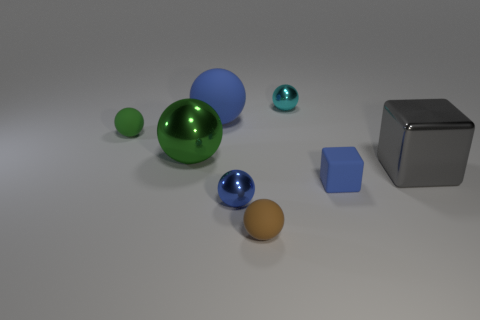Is there anything else that is the same size as the blue rubber block?
Provide a short and direct response. Yes. How many other things are the same color as the large rubber thing?
Provide a succinct answer. 2. Is the number of metallic objects that are on the right side of the tiny green matte sphere less than the number of tiny metallic balls behind the small blue metallic sphere?
Your answer should be very brief. No. How many other things are the same material as the gray cube?
Keep it short and to the point. 3. What material is the other blue thing that is the same size as the blue metallic object?
Your response must be concise. Rubber. Are there fewer shiny spheres that are behind the large rubber thing than brown metal cylinders?
Give a very brief answer. No. There is a blue matte object behind the small ball that is left of the blue object that is behind the big metallic cube; what is its shape?
Offer a very short reply. Sphere. What is the size of the blue matte object that is on the right side of the tiny cyan sphere?
Your answer should be compact. Small. There is another metal thing that is the same size as the green metal object; what is its shape?
Your answer should be compact. Cube. What number of objects are either tiny brown things or rubber spheres that are in front of the large metallic block?
Offer a very short reply. 1. 